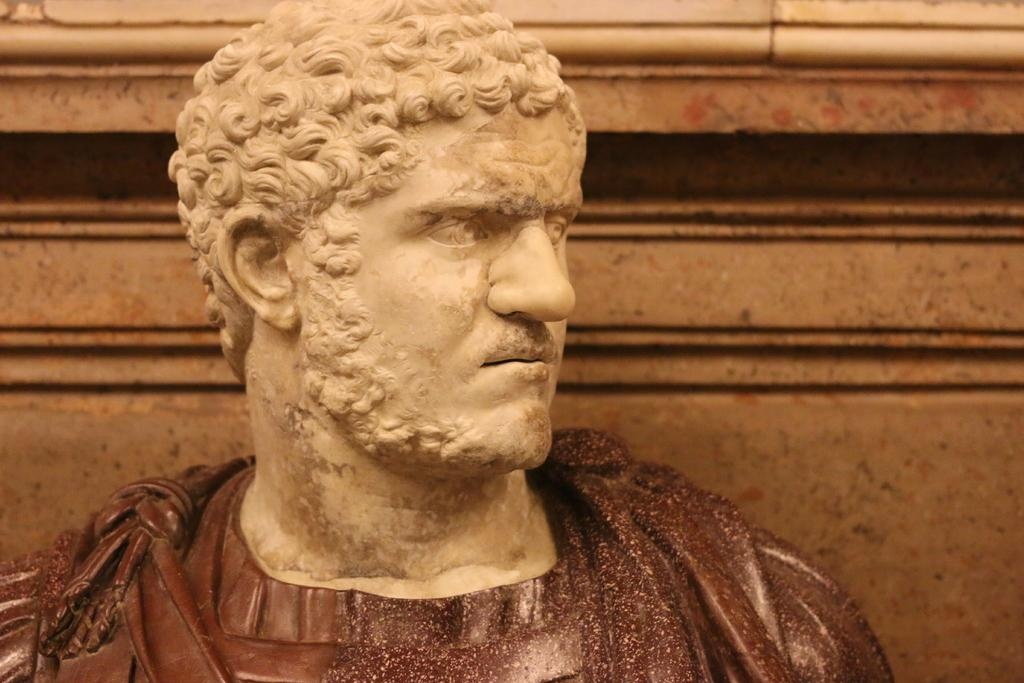What is the main subject of the image? There is a statue of a person in the image. Can you describe the setting of the image? There is a wall in the background of the image. What type of education does the person with fangs in the image have? There is no person with fangs present in the image, and therefore no information about their education can be provided. 